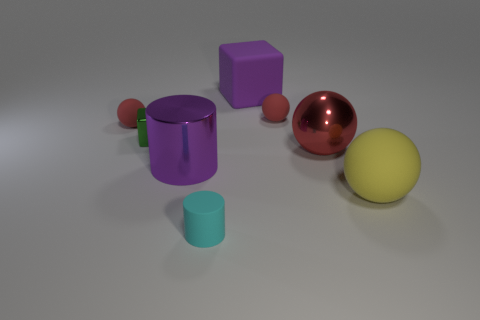What shape is the object that is the same color as the big cylinder?
Offer a terse response. Cube. Are there an equal number of small matte spheres that are behind the cyan rubber cylinder and cyan rubber cylinders that are behind the green cube?
Give a very brief answer. No. What number of objects are either large yellow objects or metallic things behind the large yellow rubber thing?
Offer a very short reply. 4. What shape is the red thing that is behind the tiny green metallic thing and on the right side of the big cylinder?
Offer a very short reply. Sphere. The ball behind the tiny red object left of the green metallic thing is made of what material?
Make the answer very short. Rubber. Do the cylinder that is in front of the yellow thing and the purple cube have the same material?
Make the answer very short. Yes. There is a yellow thing in front of the purple cylinder; how big is it?
Your answer should be compact. Large. Are there any green things to the right of the tiny red sphere to the right of the large metallic cylinder?
Your answer should be compact. No. There is a cube that is on the right side of the small cyan matte cylinder; does it have the same color as the large ball that is in front of the red metal thing?
Offer a terse response. No. The large metallic sphere has what color?
Provide a succinct answer. Red. 